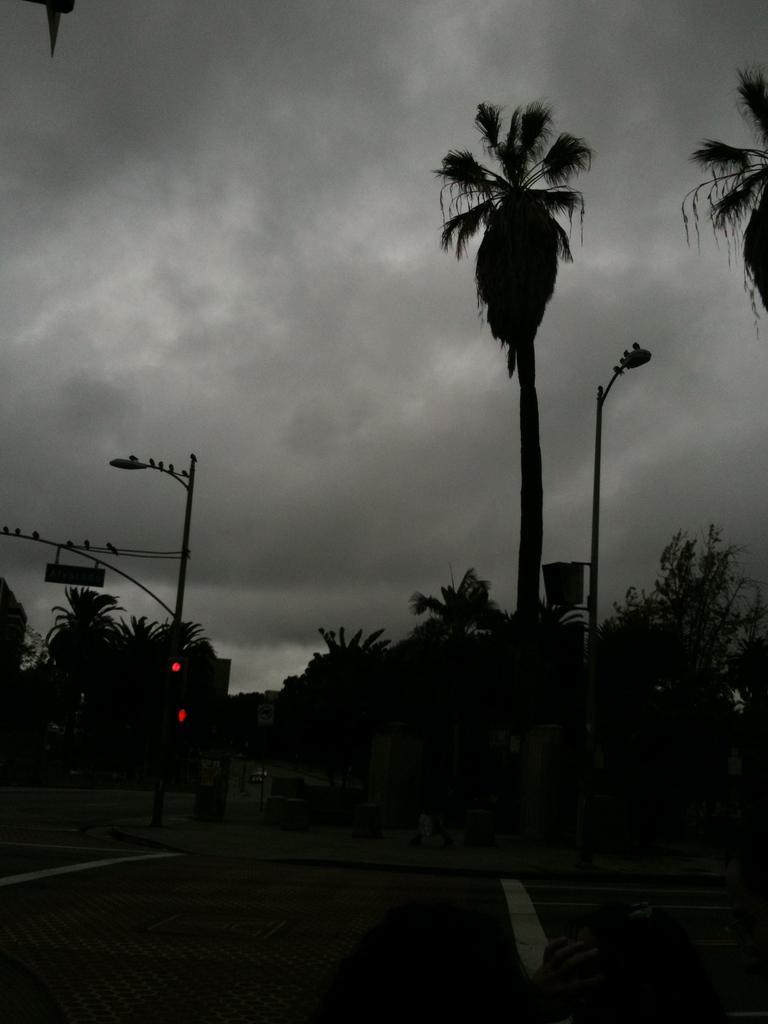Describe this image in one or two sentences. In this picture we can see the road, here we can see a traffic signal, poles, trees and some objects and we can see sky in the background. 